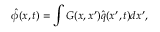<formula> <loc_0><loc_0><loc_500><loc_500>\hat { \phi } ( x , t ) = \int G ( x , x ^ { \prime } ) \hat { q } ( x ^ { \prime } , t ) d x ^ { \prime } ,</formula> 